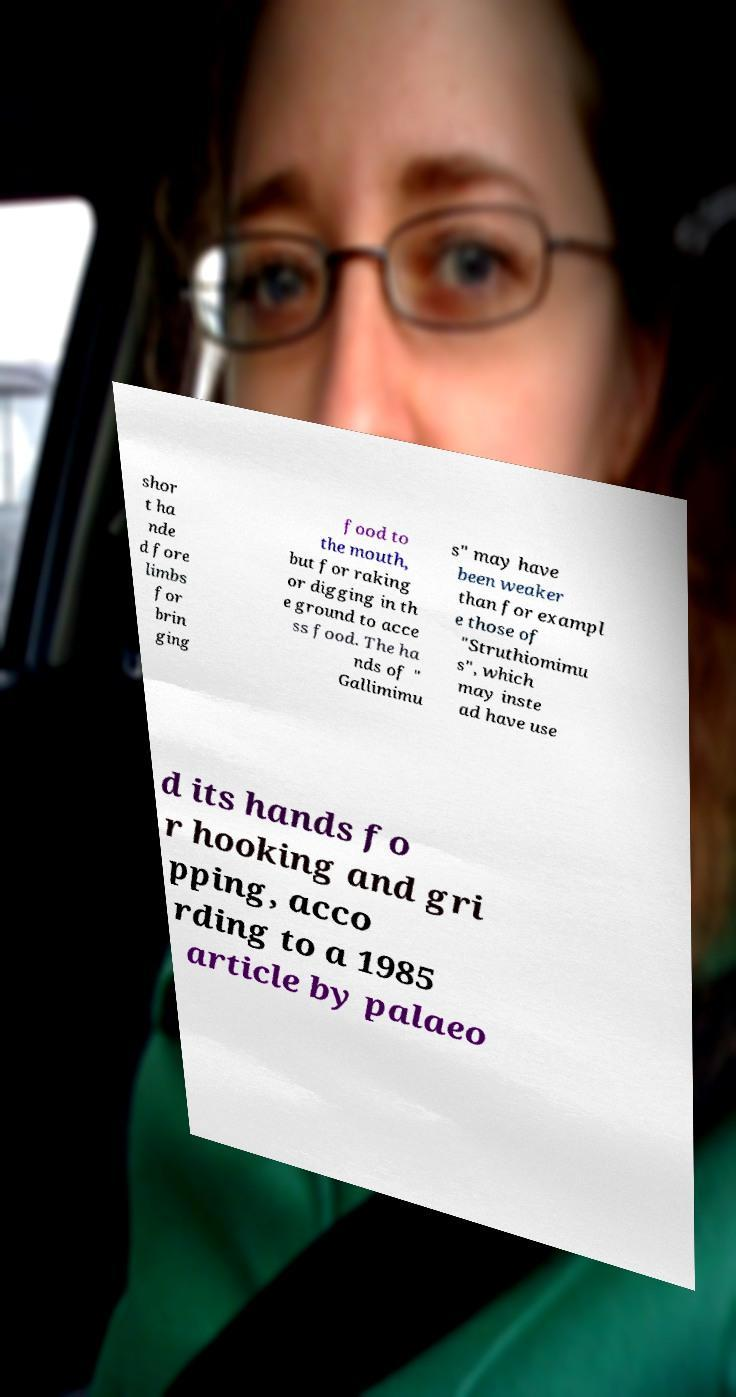Can you read and provide the text displayed in the image?This photo seems to have some interesting text. Can you extract and type it out for me? shor t ha nde d fore limbs for brin ging food to the mouth, but for raking or digging in th e ground to acce ss food. The ha nds of " Gallimimu s" may have been weaker than for exampl e those of "Struthiomimu s", which may inste ad have use d its hands fo r hooking and gri pping, acco rding to a 1985 article by palaeo 